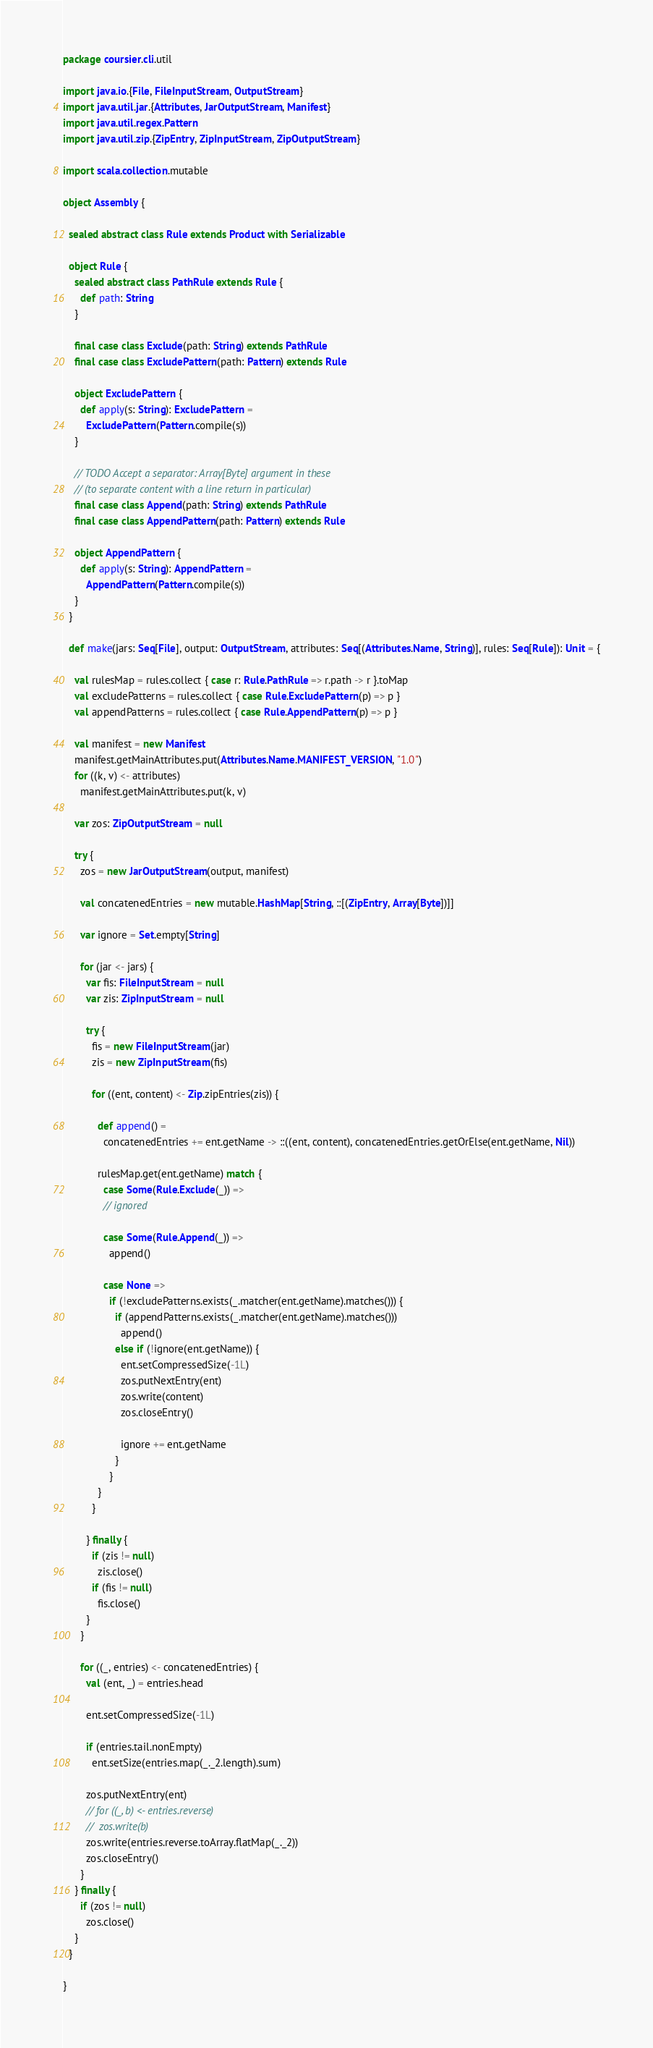<code> <loc_0><loc_0><loc_500><loc_500><_Scala_>package coursier.cli.util

import java.io.{File, FileInputStream, OutputStream}
import java.util.jar.{Attributes, JarOutputStream, Manifest}
import java.util.regex.Pattern
import java.util.zip.{ZipEntry, ZipInputStream, ZipOutputStream}

import scala.collection.mutable

object Assembly {

  sealed abstract class Rule extends Product with Serializable

  object Rule {
    sealed abstract class PathRule extends Rule {
      def path: String
    }

    final case class Exclude(path: String) extends PathRule
    final case class ExcludePattern(path: Pattern) extends Rule

    object ExcludePattern {
      def apply(s: String): ExcludePattern =
        ExcludePattern(Pattern.compile(s))
    }

    // TODO Accept a separator: Array[Byte] argument in these
    // (to separate content with a line return in particular)
    final case class Append(path: String) extends PathRule
    final case class AppendPattern(path: Pattern) extends Rule

    object AppendPattern {
      def apply(s: String): AppendPattern =
        AppendPattern(Pattern.compile(s))
    }
  }

  def make(jars: Seq[File], output: OutputStream, attributes: Seq[(Attributes.Name, String)], rules: Seq[Rule]): Unit = {

    val rulesMap = rules.collect { case r: Rule.PathRule => r.path -> r }.toMap
    val excludePatterns = rules.collect { case Rule.ExcludePattern(p) => p }
    val appendPatterns = rules.collect { case Rule.AppendPattern(p) => p }

    val manifest = new Manifest
    manifest.getMainAttributes.put(Attributes.Name.MANIFEST_VERSION, "1.0")
    for ((k, v) <- attributes)
      manifest.getMainAttributes.put(k, v)

    var zos: ZipOutputStream = null

    try {
      zos = new JarOutputStream(output, manifest)

      val concatenedEntries = new mutable.HashMap[String, ::[(ZipEntry, Array[Byte])]]

      var ignore = Set.empty[String]

      for (jar <- jars) {
        var fis: FileInputStream = null
        var zis: ZipInputStream = null

        try {
          fis = new FileInputStream(jar)
          zis = new ZipInputStream(fis)

          for ((ent, content) <- Zip.zipEntries(zis)) {

            def append() =
              concatenedEntries += ent.getName -> ::((ent, content), concatenedEntries.getOrElse(ent.getName, Nil))

            rulesMap.get(ent.getName) match {
              case Some(Rule.Exclude(_)) =>
              // ignored

              case Some(Rule.Append(_)) =>
                append()

              case None =>
                if (!excludePatterns.exists(_.matcher(ent.getName).matches())) {
                  if (appendPatterns.exists(_.matcher(ent.getName).matches()))
                    append()
                  else if (!ignore(ent.getName)) {
                    ent.setCompressedSize(-1L)
                    zos.putNextEntry(ent)
                    zos.write(content)
                    zos.closeEntry()

                    ignore += ent.getName
                  }
                }
            }
          }

        } finally {
          if (zis != null)
            zis.close()
          if (fis != null)
            fis.close()
        }
      }

      for ((_, entries) <- concatenedEntries) {
        val (ent, _) = entries.head

        ent.setCompressedSize(-1L)

        if (entries.tail.nonEmpty)
          ent.setSize(entries.map(_._2.length).sum)

        zos.putNextEntry(ent)
        // for ((_, b) <- entries.reverse)
        //  zos.write(b)
        zos.write(entries.reverse.toArray.flatMap(_._2))
        zos.closeEntry()
      }
    } finally {
      if (zos != null)
        zos.close()
    }
  }

}
</code> 